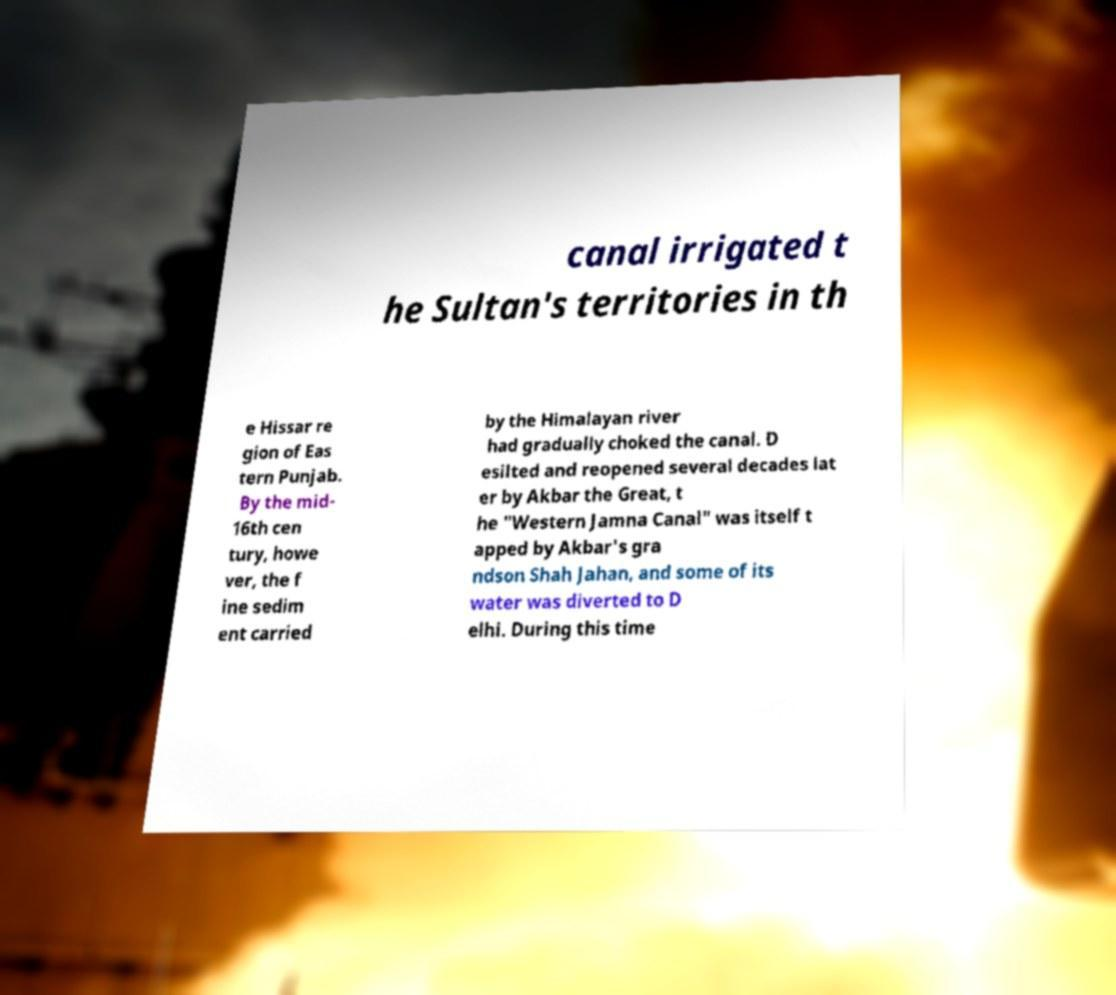There's text embedded in this image that I need extracted. Can you transcribe it verbatim? canal irrigated t he Sultan's territories in th e Hissar re gion of Eas tern Punjab. By the mid- 16th cen tury, howe ver, the f ine sedim ent carried by the Himalayan river had gradually choked the canal. D esilted and reopened several decades lat er by Akbar the Great, t he "Western Jamna Canal" was itself t apped by Akbar's gra ndson Shah Jahan, and some of its water was diverted to D elhi. During this time 